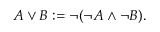<formula> <loc_0><loc_0><loc_500><loc_500>A \lor B \colon = \neg ( \neg A \land \neg B ) .</formula> 